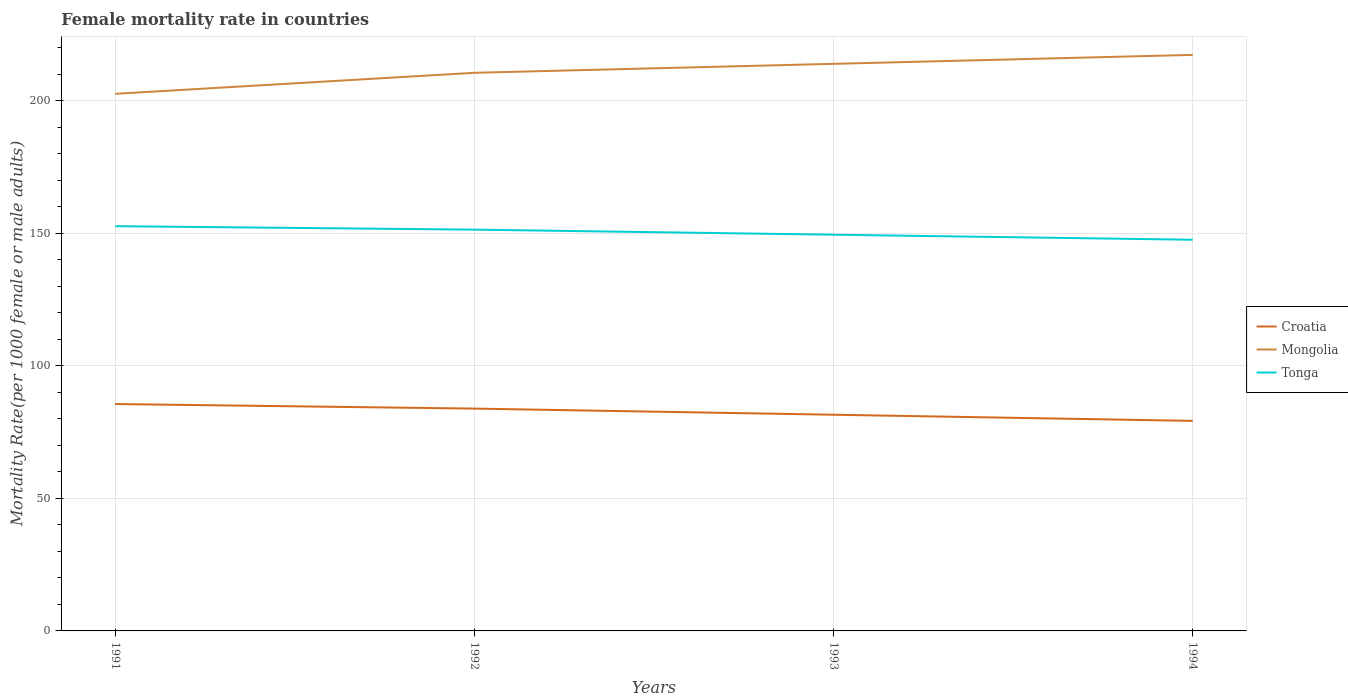How many different coloured lines are there?
Your answer should be very brief. 3. Across all years, what is the maximum female mortality rate in Mongolia?
Make the answer very short. 202.58. In which year was the female mortality rate in Mongolia maximum?
Your response must be concise. 1991. What is the total female mortality rate in Croatia in the graph?
Provide a succinct answer. 1.72. What is the difference between the highest and the second highest female mortality rate in Mongolia?
Your answer should be very brief. 14.69. What is the difference between the highest and the lowest female mortality rate in Mongolia?
Your answer should be very brief. 2. What is the difference between two consecutive major ticks on the Y-axis?
Provide a short and direct response. 50. Does the graph contain any zero values?
Offer a terse response. No. Does the graph contain grids?
Provide a succinct answer. Yes. How many legend labels are there?
Provide a succinct answer. 3. What is the title of the graph?
Provide a short and direct response. Female mortality rate in countries. Does "Jamaica" appear as one of the legend labels in the graph?
Your answer should be compact. No. What is the label or title of the X-axis?
Offer a terse response. Years. What is the label or title of the Y-axis?
Provide a short and direct response. Mortality Rate(per 1000 female or male adults). What is the Mortality Rate(per 1000 female or male adults) of Croatia in 1991?
Offer a terse response. 85.58. What is the Mortality Rate(per 1000 female or male adults) in Mongolia in 1991?
Your response must be concise. 202.58. What is the Mortality Rate(per 1000 female or male adults) in Tonga in 1991?
Provide a succinct answer. 152.66. What is the Mortality Rate(per 1000 female or male adults) in Croatia in 1992?
Your answer should be very brief. 83.86. What is the Mortality Rate(per 1000 female or male adults) in Mongolia in 1992?
Keep it short and to the point. 210.51. What is the Mortality Rate(per 1000 female or male adults) of Tonga in 1992?
Your answer should be compact. 151.35. What is the Mortality Rate(per 1000 female or male adults) of Croatia in 1993?
Provide a succinct answer. 81.54. What is the Mortality Rate(per 1000 female or male adults) in Mongolia in 1993?
Your answer should be very brief. 213.89. What is the Mortality Rate(per 1000 female or male adults) in Tonga in 1993?
Give a very brief answer. 149.44. What is the Mortality Rate(per 1000 female or male adults) of Croatia in 1994?
Make the answer very short. 79.22. What is the Mortality Rate(per 1000 female or male adults) of Mongolia in 1994?
Provide a succinct answer. 217.27. What is the Mortality Rate(per 1000 female or male adults) of Tonga in 1994?
Provide a succinct answer. 147.54. Across all years, what is the maximum Mortality Rate(per 1000 female or male adults) in Croatia?
Your answer should be compact. 85.58. Across all years, what is the maximum Mortality Rate(per 1000 female or male adults) in Mongolia?
Provide a succinct answer. 217.27. Across all years, what is the maximum Mortality Rate(per 1000 female or male adults) of Tonga?
Give a very brief answer. 152.66. Across all years, what is the minimum Mortality Rate(per 1000 female or male adults) of Croatia?
Your answer should be very brief. 79.22. Across all years, what is the minimum Mortality Rate(per 1000 female or male adults) of Mongolia?
Make the answer very short. 202.58. Across all years, what is the minimum Mortality Rate(per 1000 female or male adults) of Tonga?
Make the answer very short. 147.54. What is the total Mortality Rate(per 1000 female or male adults) in Croatia in the graph?
Provide a short and direct response. 330.19. What is the total Mortality Rate(per 1000 female or male adults) in Mongolia in the graph?
Your answer should be very brief. 844.25. What is the total Mortality Rate(per 1000 female or male adults) in Tonga in the graph?
Your response must be concise. 600.99. What is the difference between the Mortality Rate(per 1000 female or male adults) in Croatia in 1991 and that in 1992?
Give a very brief answer. 1.72. What is the difference between the Mortality Rate(per 1000 female or male adults) in Mongolia in 1991 and that in 1992?
Your response must be concise. -7.93. What is the difference between the Mortality Rate(per 1000 female or male adults) of Tonga in 1991 and that in 1992?
Make the answer very short. 1.3. What is the difference between the Mortality Rate(per 1000 female or male adults) in Croatia in 1991 and that in 1993?
Offer a very short reply. 4.04. What is the difference between the Mortality Rate(per 1000 female or male adults) of Mongolia in 1991 and that in 1993?
Provide a succinct answer. -11.31. What is the difference between the Mortality Rate(per 1000 female or male adults) in Tonga in 1991 and that in 1993?
Make the answer very short. 3.21. What is the difference between the Mortality Rate(per 1000 female or male adults) in Croatia in 1991 and that in 1994?
Keep it short and to the point. 6.35. What is the difference between the Mortality Rate(per 1000 female or male adults) in Mongolia in 1991 and that in 1994?
Make the answer very short. -14.69. What is the difference between the Mortality Rate(per 1000 female or male adults) of Tonga in 1991 and that in 1994?
Offer a terse response. 5.12. What is the difference between the Mortality Rate(per 1000 female or male adults) in Croatia in 1992 and that in 1993?
Offer a terse response. 2.32. What is the difference between the Mortality Rate(per 1000 female or male adults) in Mongolia in 1992 and that in 1993?
Offer a terse response. -3.38. What is the difference between the Mortality Rate(per 1000 female or male adults) of Tonga in 1992 and that in 1993?
Provide a short and direct response. 1.91. What is the difference between the Mortality Rate(per 1000 female or male adults) of Croatia in 1992 and that in 1994?
Offer a very short reply. 4.63. What is the difference between the Mortality Rate(per 1000 female or male adults) of Mongolia in 1992 and that in 1994?
Your response must be concise. -6.76. What is the difference between the Mortality Rate(per 1000 female or male adults) in Tonga in 1992 and that in 1994?
Your response must be concise. 3.81. What is the difference between the Mortality Rate(per 1000 female or male adults) in Croatia in 1993 and that in 1994?
Your answer should be compact. 2.32. What is the difference between the Mortality Rate(per 1000 female or male adults) of Mongolia in 1993 and that in 1994?
Offer a terse response. -3.38. What is the difference between the Mortality Rate(per 1000 female or male adults) of Tonga in 1993 and that in 1994?
Your answer should be compact. 1.91. What is the difference between the Mortality Rate(per 1000 female or male adults) in Croatia in 1991 and the Mortality Rate(per 1000 female or male adults) in Mongolia in 1992?
Ensure brevity in your answer.  -124.94. What is the difference between the Mortality Rate(per 1000 female or male adults) in Croatia in 1991 and the Mortality Rate(per 1000 female or male adults) in Tonga in 1992?
Provide a short and direct response. -65.77. What is the difference between the Mortality Rate(per 1000 female or male adults) of Mongolia in 1991 and the Mortality Rate(per 1000 female or male adults) of Tonga in 1992?
Provide a short and direct response. 51.23. What is the difference between the Mortality Rate(per 1000 female or male adults) of Croatia in 1991 and the Mortality Rate(per 1000 female or male adults) of Mongolia in 1993?
Offer a terse response. -128.31. What is the difference between the Mortality Rate(per 1000 female or male adults) in Croatia in 1991 and the Mortality Rate(per 1000 female or male adults) in Tonga in 1993?
Keep it short and to the point. -63.87. What is the difference between the Mortality Rate(per 1000 female or male adults) in Mongolia in 1991 and the Mortality Rate(per 1000 female or male adults) in Tonga in 1993?
Offer a terse response. 53.14. What is the difference between the Mortality Rate(per 1000 female or male adults) in Croatia in 1991 and the Mortality Rate(per 1000 female or male adults) in Mongolia in 1994?
Keep it short and to the point. -131.69. What is the difference between the Mortality Rate(per 1000 female or male adults) of Croatia in 1991 and the Mortality Rate(per 1000 female or male adults) of Tonga in 1994?
Offer a terse response. -61.96. What is the difference between the Mortality Rate(per 1000 female or male adults) in Mongolia in 1991 and the Mortality Rate(per 1000 female or male adults) in Tonga in 1994?
Keep it short and to the point. 55.04. What is the difference between the Mortality Rate(per 1000 female or male adults) of Croatia in 1992 and the Mortality Rate(per 1000 female or male adults) of Mongolia in 1993?
Keep it short and to the point. -130.03. What is the difference between the Mortality Rate(per 1000 female or male adults) in Croatia in 1992 and the Mortality Rate(per 1000 female or male adults) in Tonga in 1993?
Offer a very short reply. -65.59. What is the difference between the Mortality Rate(per 1000 female or male adults) in Mongolia in 1992 and the Mortality Rate(per 1000 female or male adults) in Tonga in 1993?
Your response must be concise. 61.07. What is the difference between the Mortality Rate(per 1000 female or male adults) of Croatia in 1992 and the Mortality Rate(per 1000 female or male adults) of Mongolia in 1994?
Provide a short and direct response. -133.41. What is the difference between the Mortality Rate(per 1000 female or male adults) of Croatia in 1992 and the Mortality Rate(per 1000 female or male adults) of Tonga in 1994?
Your response must be concise. -63.68. What is the difference between the Mortality Rate(per 1000 female or male adults) in Mongolia in 1992 and the Mortality Rate(per 1000 female or male adults) in Tonga in 1994?
Give a very brief answer. 62.97. What is the difference between the Mortality Rate(per 1000 female or male adults) of Croatia in 1993 and the Mortality Rate(per 1000 female or male adults) of Mongolia in 1994?
Your response must be concise. -135.73. What is the difference between the Mortality Rate(per 1000 female or male adults) of Croatia in 1993 and the Mortality Rate(per 1000 female or male adults) of Tonga in 1994?
Ensure brevity in your answer.  -66. What is the difference between the Mortality Rate(per 1000 female or male adults) in Mongolia in 1993 and the Mortality Rate(per 1000 female or male adults) in Tonga in 1994?
Make the answer very short. 66.35. What is the average Mortality Rate(per 1000 female or male adults) in Croatia per year?
Provide a succinct answer. 82.55. What is the average Mortality Rate(per 1000 female or male adults) in Mongolia per year?
Your response must be concise. 211.06. What is the average Mortality Rate(per 1000 female or male adults) in Tonga per year?
Make the answer very short. 150.25. In the year 1991, what is the difference between the Mortality Rate(per 1000 female or male adults) of Croatia and Mortality Rate(per 1000 female or male adults) of Mongolia?
Offer a terse response. -117. In the year 1991, what is the difference between the Mortality Rate(per 1000 female or male adults) in Croatia and Mortality Rate(per 1000 female or male adults) in Tonga?
Keep it short and to the point. -67.08. In the year 1991, what is the difference between the Mortality Rate(per 1000 female or male adults) of Mongolia and Mortality Rate(per 1000 female or male adults) of Tonga?
Offer a terse response. 49.93. In the year 1992, what is the difference between the Mortality Rate(per 1000 female or male adults) of Croatia and Mortality Rate(per 1000 female or male adults) of Mongolia?
Your response must be concise. -126.66. In the year 1992, what is the difference between the Mortality Rate(per 1000 female or male adults) of Croatia and Mortality Rate(per 1000 female or male adults) of Tonga?
Your answer should be compact. -67.5. In the year 1992, what is the difference between the Mortality Rate(per 1000 female or male adults) in Mongolia and Mortality Rate(per 1000 female or male adults) in Tonga?
Your response must be concise. 59.16. In the year 1993, what is the difference between the Mortality Rate(per 1000 female or male adults) of Croatia and Mortality Rate(per 1000 female or male adults) of Mongolia?
Provide a short and direct response. -132.35. In the year 1993, what is the difference between the Mortality Rate(per 1000 female or male adults) of Croatia and Mortality Rate(per 1000 female or male adults) of Tonga?
Your answer should be compact. -67.91. In the year 1993, what is the difference between the Mortality Rate(per 1000 female or male adults) in Mongolia and Mortality Rate(per 1000 female or male adults) in Tonga?
Your response must be concise. 64.45. In the year 1994, what is the difference between the Mortality Rate(per 1000 female or male adults) of Croatia and Mortality Rate(per 1000 female or male adults) of Mongolia?
Your answer should be compact. -138.05. In the year 1994, what is the difference between the Mortality Rate(per 1000 female or male adults) in Croatia and Mortality Rate(per 1000 female or male adults) in Tonga?
Your answer should be very brief. -68.32. In the year 1994, what is the difference between the Mortality Rate(per 1000 female or male adults) in Mongolia and Mortality Rate(per 1000 female or male adults) in Tonga?
Offer a terse response. 69.73. What is the ratio of the Mortality Rate(per 1000 female or male adults) in Croatia in 1991 to that in 1992?
Make the answer very short. 1.02. What is the ratio of the Mortality Rate(per 1000 female or male adults) in Mongolia in 1991 to that in 1992?
Offer a very short reply. 0.96. What is the ratio of the Mortality Rate(per 1000 female or male adults) of Tonga in 1991 to that in 1992?
Offer a very short reply. 1.01. What is the ratio of the Mortality Rate(per 1000 female or male adults) in Croatia in 1991 to that in 1993?
Make the answer very short. 1.05. What is the ratio of the Mortality Rate(per 1000 female or male adults) of Mongolia in 1991 to that in 1993?
Your answer should be very brief. 0.95. What is the ratio of the Mortality Rate(per 1000 female or male adults) of Tonga in 1991 to that in 1993?
Ensure brevity in your answer.  1.02. What is the ratio of the Mortality Rate(per 1000 female or male adults) in Croatia in 1991 to that in 1994?
Make the answer very short. 1.08. What is the ratio of the Mortality Rate(per 1000 female or male adults) in Mongolia in 1991 to that in 1994?
Keep it short and to the point. 0.93. What is the ratio of the Mortality Rate(per 1000 female or male adults) in Tonga in 1991 to that in 1994?
Make the answer very short. 1.03. What is the ratio of the Mortality Rate(per 1000 female or male adults) of Croatia in 1992 to that in 1993?
Ensure brevity in your answer.  1.03. What is the ratio of the Mortality Rate(per 1000 female or male adults) in Mongolia in 1992 to that in 1993?
Make the answer very short. 0.98. What is the ratio of the Mortality Rate(per 1000 female or male adults) in Tonga in 1992 to that in 1993?
Your response must be concise. 1.01. What is the ratio of the Mortality Rate(per 1000 female or male adults) in Croatia in 1992 to that in 1994?
Provide a short and direct response. 1.06. What is the ratio of the Mortality Rate(per 1000 female or male adults) of Mongolia in 1992 to that in 1994?
Keep it short and to the point. 0.97. What is the ratio of the Mortality Rate(per 1000 female or male adults) in Tonga in 1992 to that in 1994?
Your answer should be compact. 1.03. What is the ratio of the Mortality Rate(per 1000 female or male adults) of Croatia in 1993 to that in 1994?
Ensure brevity in your answer.  1.03. What is the ratio of the Mortality Rate(per 1000 female or male adults) in Mongolia in 1993 to that in 1994?
Provide a short and direct response. 0.98. What is the ratio of the Mortality Rate(per 1000 female or male adults) of Tonga in 1993 to that in 1994?
Keep it short and to the point. 1.01. What is the difference between the highest and the second highest Mortality Rate(per 1000 female or male adults) in Croatia?
Your response must be concise. 1.72. What is the difference between the highest and the second highest Mortality Rate(per 1000 female or male adults) in Mongolia?
Offer a very short reply. 3.38. What is the difference between the highest and the second highest Mortality Rate(per 1000 female or male adults) of Tonga?
Keep it short and to the point. 1.3. What is the difference between the highest and the lowest Mortality Rate(per 1000 female or male adults) in Croatia?
Your answer should be compact. 6.35. What is the difference between the highest and the lowest Mortality Rate(per 1000 female or male adults) of Mongolia?
Give a very brief answer. 14.69. What is the difference between the highest and the lowest Mortality Rate(per 1000 female or male adults) of Tonga?
Offer a terse response. 5.12. 